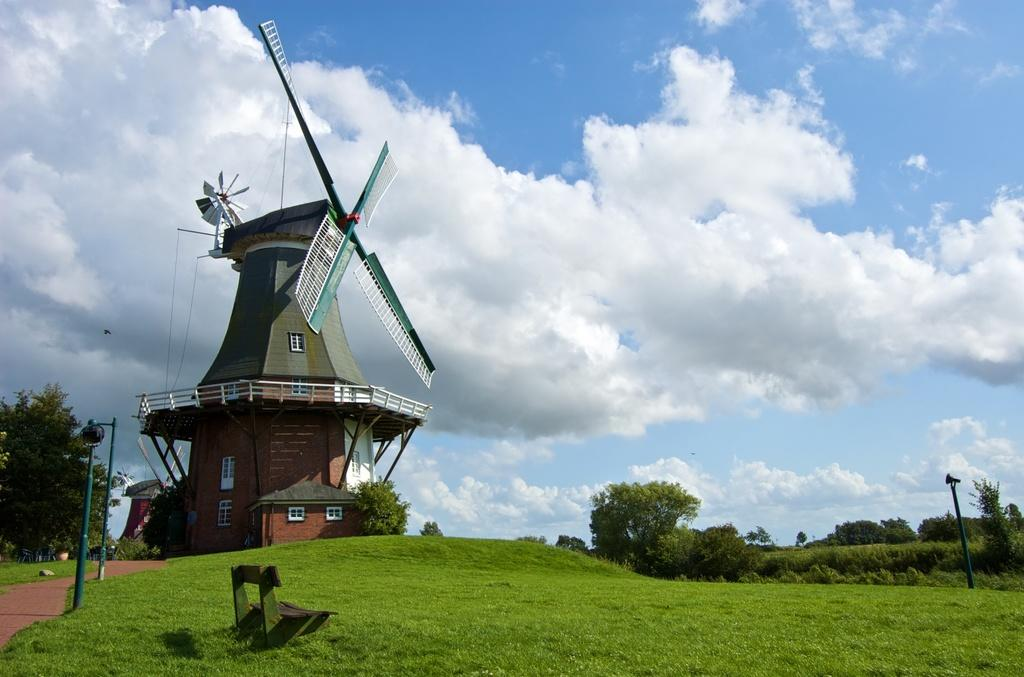What type of vegetation is present in the image? There is grass in the image. What type of seating is available in the image? There is a bench in the image. What type of structures are present in the image? There are poles and a building in the image. What type of natural features are present in the image? There are trees in the image. What is visible in the background of the image? The sky is visible in the background of the image. What is the weather like in the image? The sky has heavy clouds, suggesting a potentially overcast or stormy day. Can you see any ants crawling on the bench in the image? There are no ants visible in the image. What type of cannon is present in the image? There is no cannon present in the image. Is there a carpenter working on the building in the image? There is no indication of a carpenter or any construction work in the image. 